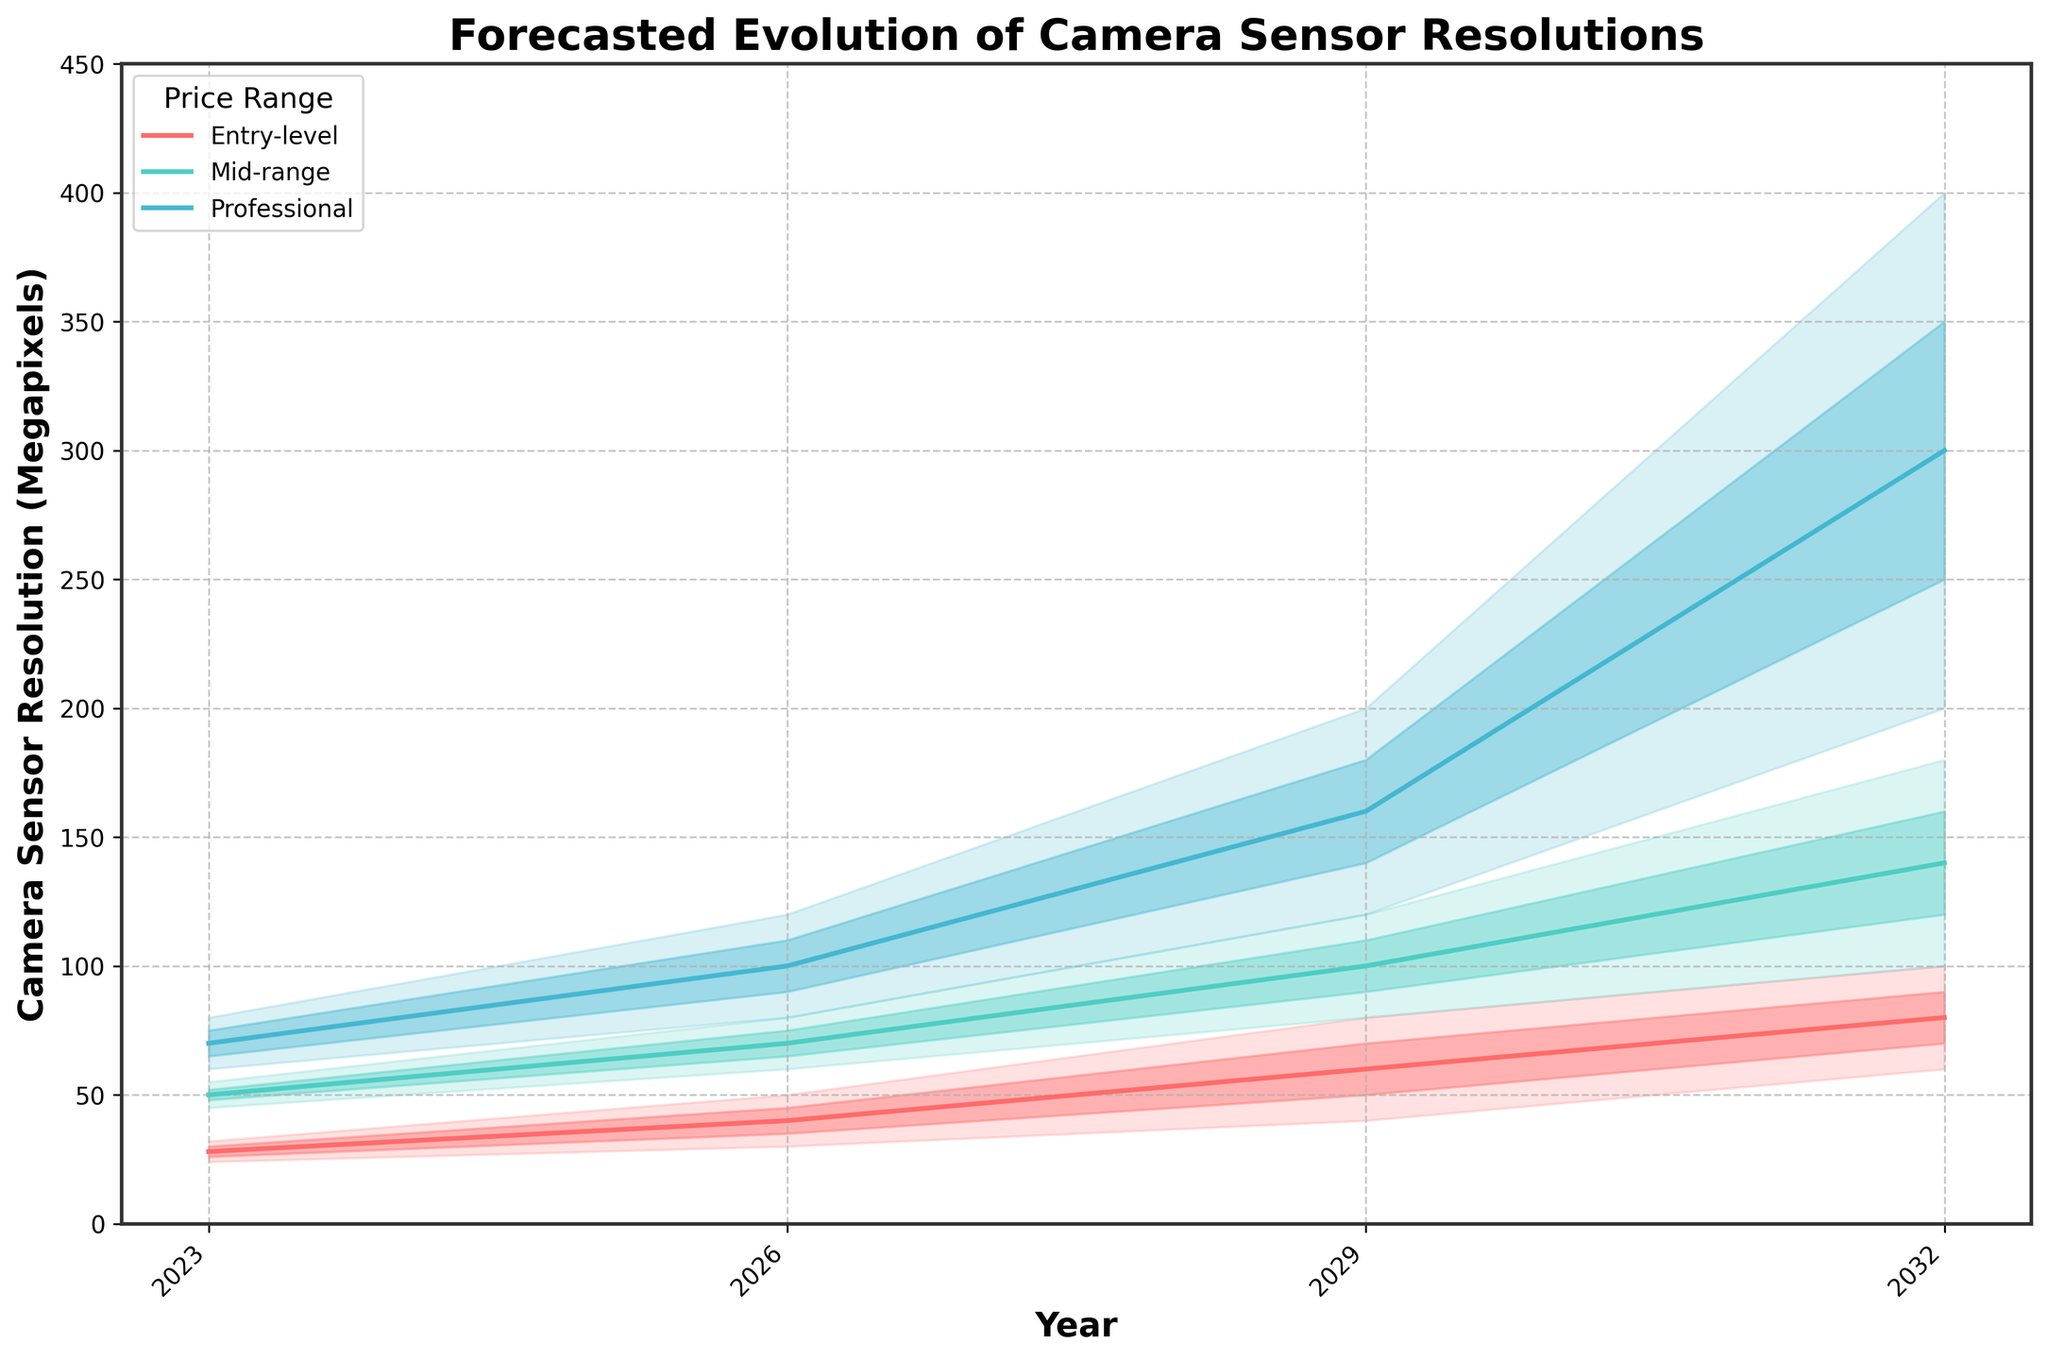What is the title of the figure? The title of the figure is located at the top and it summarizes the main subject of the plot. By looking at the figure, it's easy to read the main title directly.
Answer: Forecasted Evolution of Camera Sensor Resolutions What are the different price ranges displayed in the figure? The legend on the plot, located at the upper left, indicates the different price ranges. These can be read easily by looking at the legend.
Answer: Entry-level, Mid-range, Professional In which year is the highest estimate for professional cameras forecasted to be 400 megapixels? Look at the shaded areas and lines representing professional cameras, then find the year where the top boundary reaches 400 megapixels.
Answer: 2032 By how much is the median estimate for mid-range cameras forecasted to increase from 2023 to 2029? First, find the median estimates for mid-range cameras in 2023 and 2029 by following the relevant lines on the graph. Then, subtract the median estimate in 2023 from the median estimate in 2029.
Answer: 60 megapixels Which price range has the least growth in its lowest estimates between 2023 and 2032? Compare the growth of the lowest estimates for each price range from 2023 to 2032 by examining the lower boundaries of the shaded areas. Calculate the difference for each to determine which has the least growth.
Answer: Mid-range What is the forecasted range of camera sensor resolution for entry-level cameras in 2026? The forecasted range can be determined by identifying the lowest and highest estimates for the entry-level cameras in the year 2026, indicated by the boundaries of the shaded area.
Answer: 30 to 50 megapixels Which year shows the highest overlap in resolution estimates between entry-level and mid-range cameras? Find the years where the shaded areas of entry-level and mid-range cameras overlap the most. The year with the largest common area will be the answer.
Answer: 2029 How much higher is the mid-estimate for professional cameras in 2032 compared to mid-range cameras in the same year? Identify the mid-estimates for professional and mid-range cameras in 2032 by looking at the central lines. Subtract the mid-estimate for mid-range from the mid-estimate for professional cameras.
Answer: 160 megapixels 